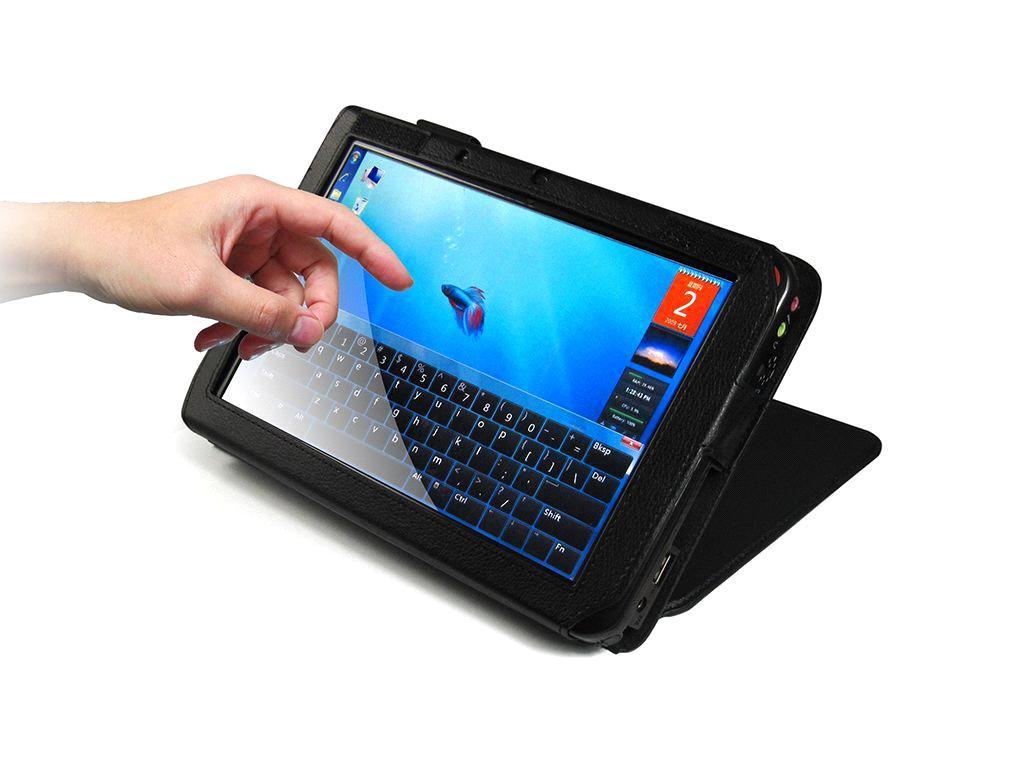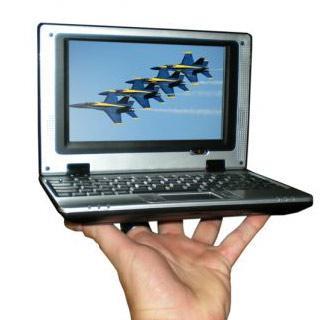The first image is the image on the left, the second image is the image on the right. Analyze the images presented: Is the assertion "The laptop on the left image has a silver body around the keyboard." valid? Answer yes or no. No. 